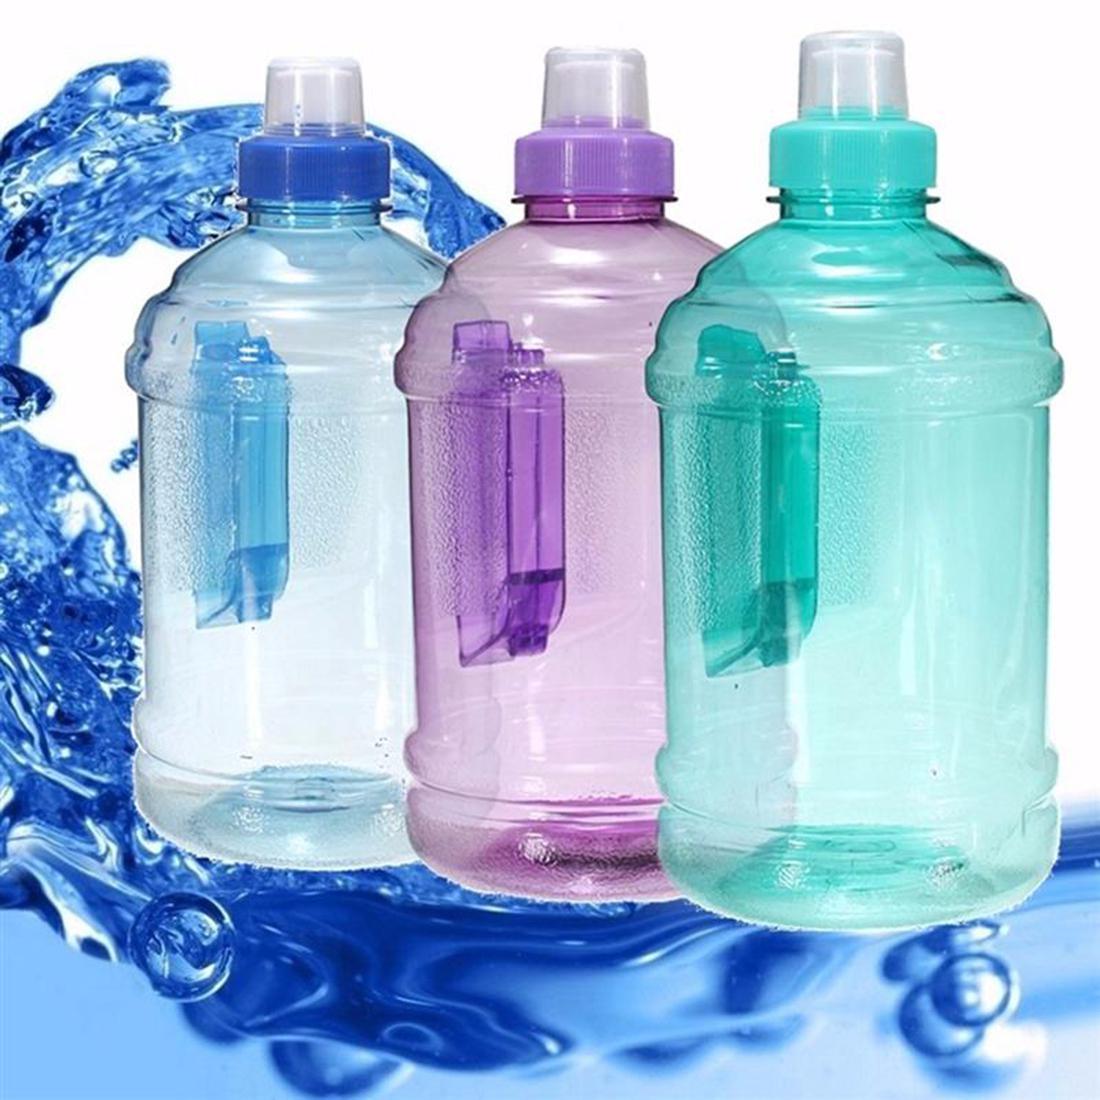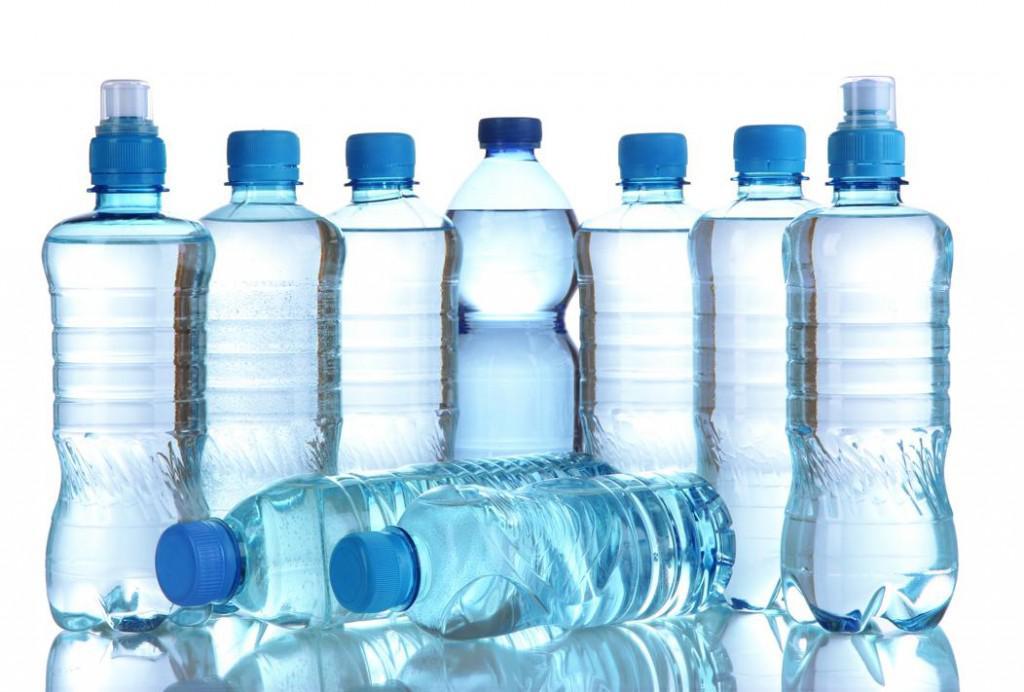The first image is the image on the left, the second image is the image on the right. Evaluate the accuracy of this statement regarding the images: "There are three bottles in one of the images.". Is it true? Answer yes or no. Yes. 